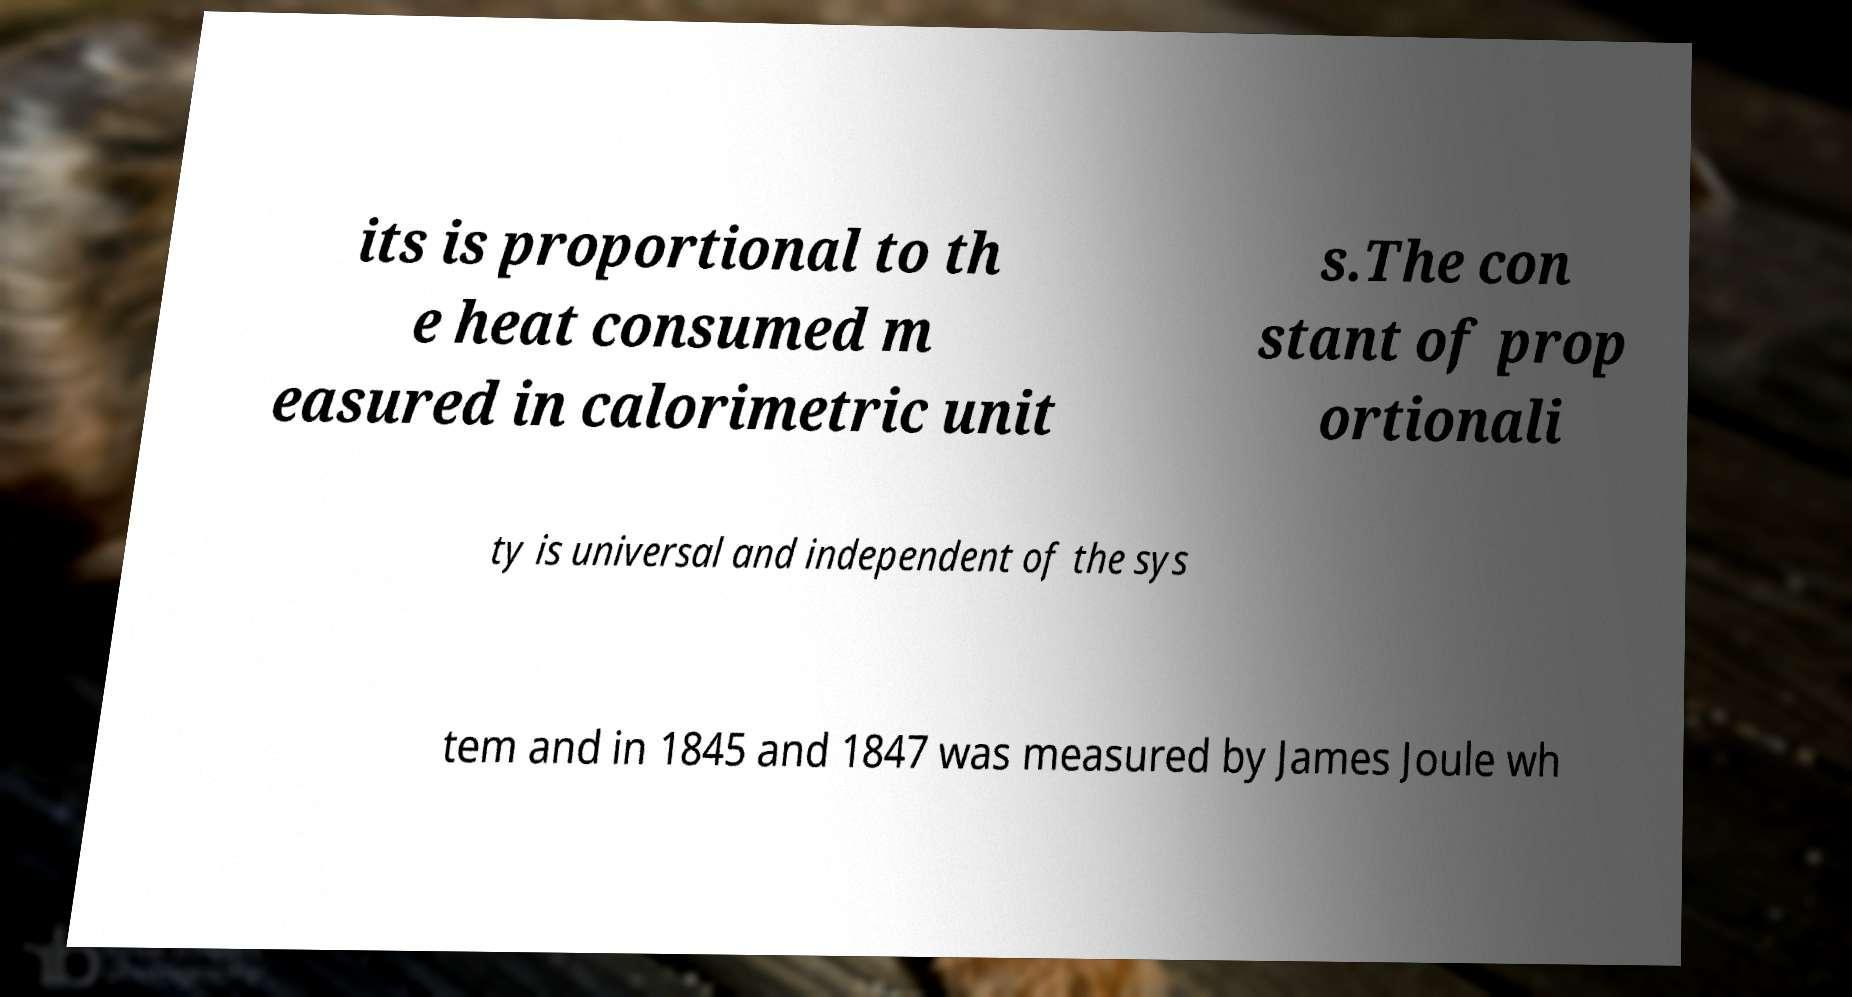Please identify and transcribe the text found in this image. its is proportional to th e heat consumed m easured in calorimetric unit s.The con stant of prop ortionali ty is universal and independent of the sys tem and in 1845 and 1847 was measured by James Joule wh 